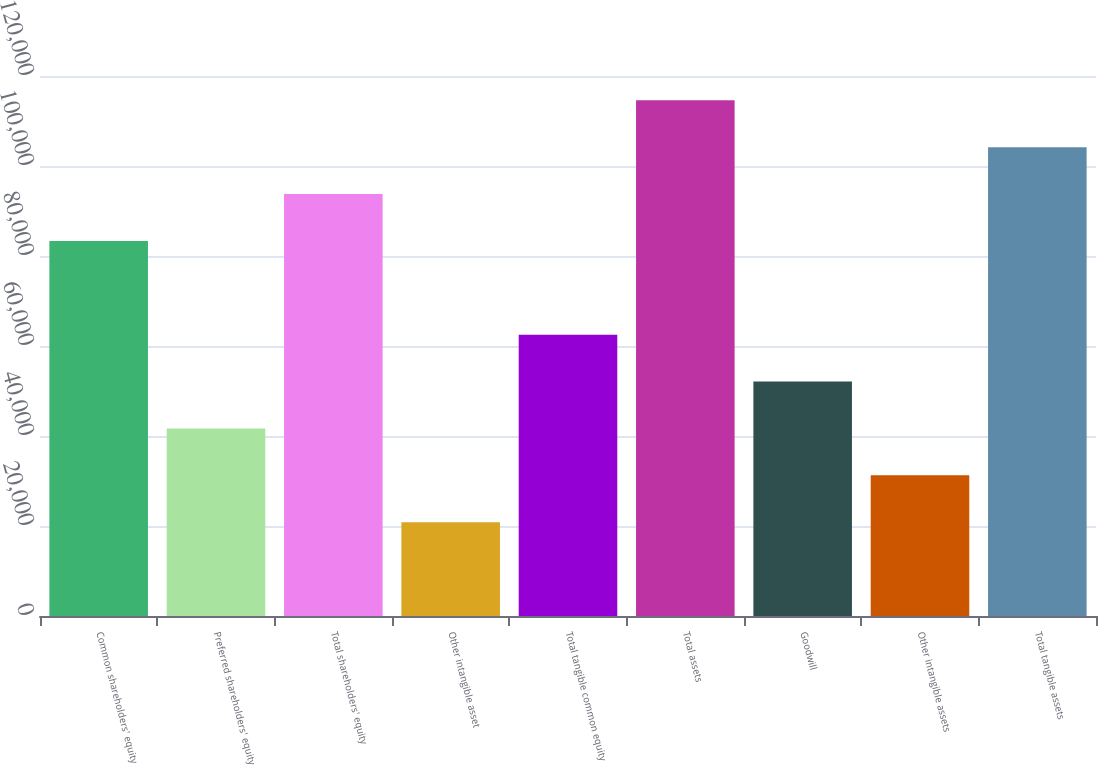<chart> <loc_0><loc_0><loc_500><loc_500><bar_chart><fcel>Common shareholders' equity<fcel>Preferred shareholders' equity<fcel>Total shareholders' equity<fcel>Other intangible asset<fcel>Total tangible common equity<fcel>Total assets<fcel>Goodwill<fcel>Other intangible assets<fcel>Total tangible assets<nl><fcel>83349.5<fcel>41678.4<fcel>93767.3<fcel>20842.9<fcel>62514<fcel>114603<fcel>52096.2<fcel>31260.7<fcel>104185<nl></chart> 